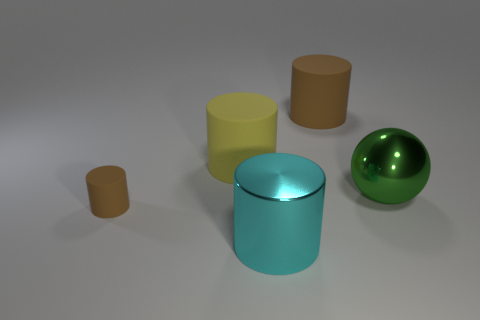There is a big matte thing that is on the left side of the metal cylinder in front of the big yellow rubber object; what color is it? The object in question is a brown matte cylinder, which is positioned to the left of the central metal cylinder that possesses a reflective teal surface. 